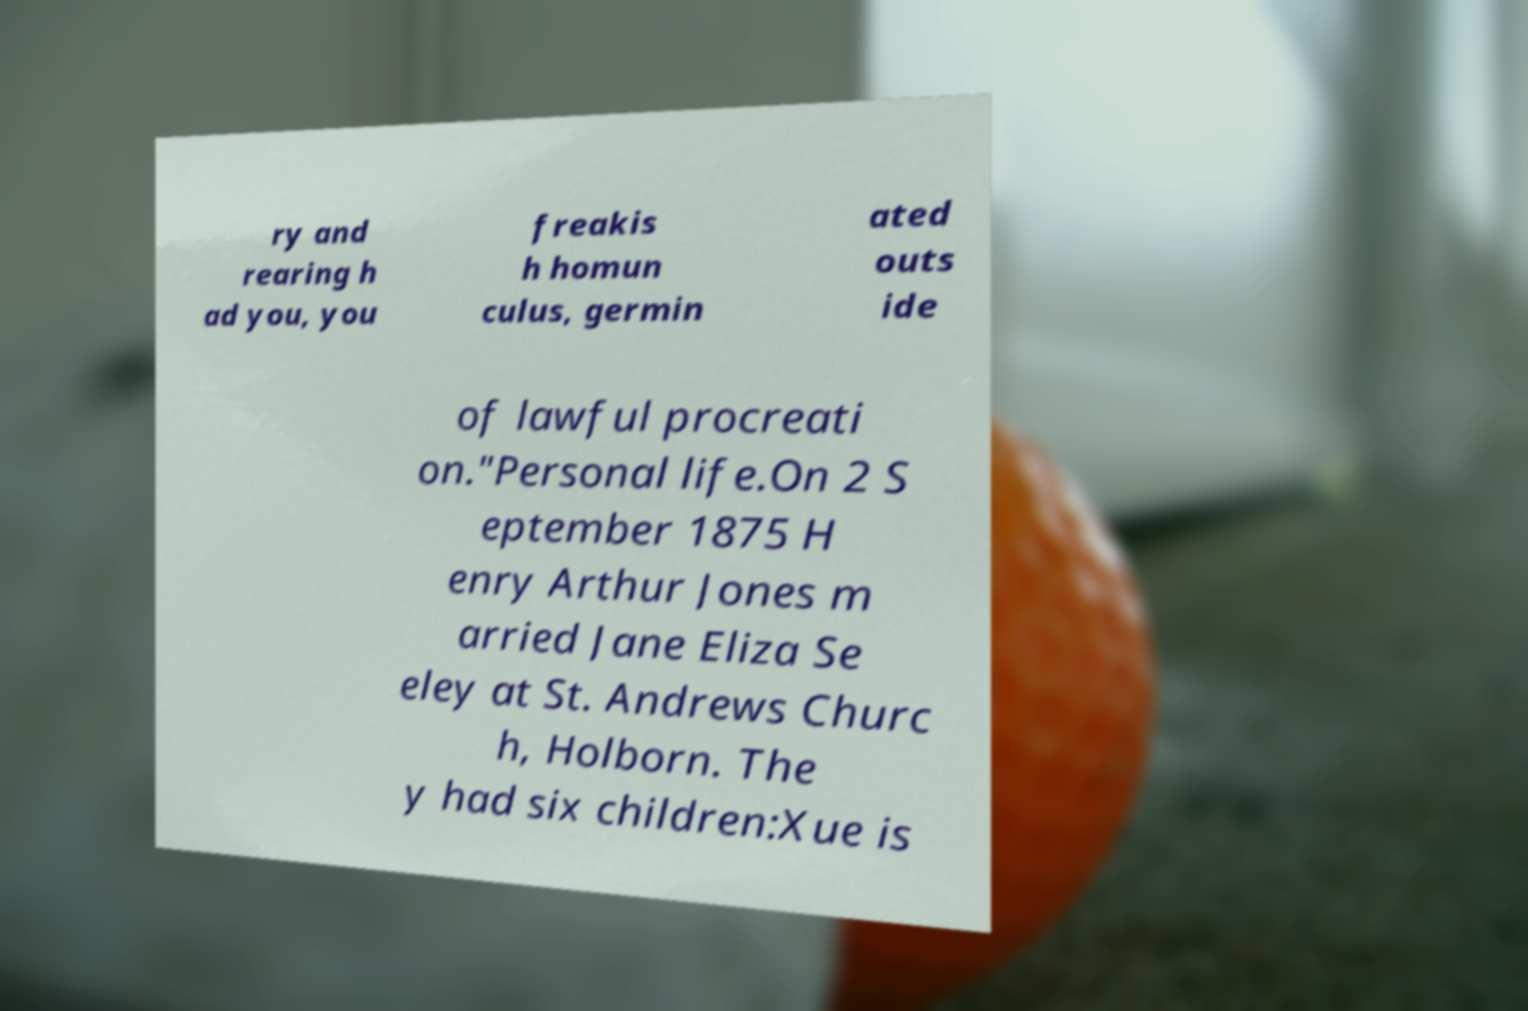Can you accurately transcribe the text from the provided image for me? ry and rearing h ad you, you freakis h homun culus, germin ated outs ide of lawful procreati on."Personal life.On 2 S eptember 1875 H enry Arthur Jones m arried Jane Eliza Se eley at St. Andrews Churc h, Holborn. The y had six children:Xue is 